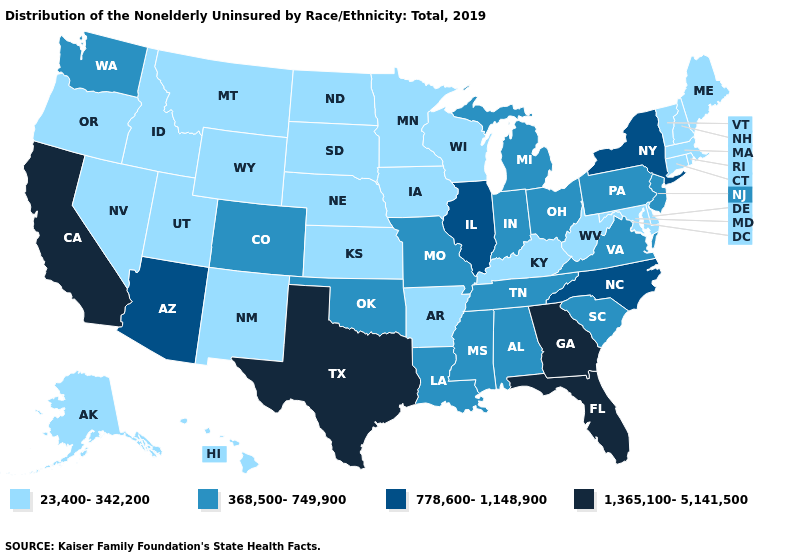Name the states that have a value in the range 23,400-342,200?
Write a very short answer. Alaska, Arkansas, Connecticut, Delaware, Hawaii, Idaho, Iowa, Kansas, Kentucky, Maine, Maryland, Massachusetts, Minnesota, Montana, Nebraska, Nevada, New Hampshire, New Mexico, North Dakota, Oregon, Rhode Island, South Dakota, Utah, Vermont, West Virginia, Wisconsin, Wyoming. Name the states that have a value in the range 778,600-1,148,900?
Write a very short answer. Arizona, Illinois, New York, North Carolina. Does West Virginia have the lowest value in the South?
Write a very short answer. Yes. What is the highest value in the USA?
Concise answer only. 1,365,100-5,141,500. Does the map have missing data?
Keep it brief. No. Name the states that have a value in the range 368,500-749,900?
Write a very short answer. Alabama, Colorado, Indiana, Louisiana, Michigan, Mississippi, Missouri, New Jersey, Ohio, Oklahoma, Pennsylvania, South Carolina, Tennessee, Virginia, Washington. Among the states that border Illinois , which have the highest value?
Write a very short answer. Indiana, Missouri. Name the states that have a value in the range 23,400-342,200?
Short answer required. Alaska, Arkansas, Connecticut, Delaware, Hawaii, Idaho, Iowa, Kansas, Kentucky, Maine, Maryland, Massachusetts, Minnesota, Montana, Nebraska, Nevada, New Hampshire, New Mexico, North Dakota, Oregon, Rhode Island, South Dakota, Utah, Vermont, West Virginia, Wisconsin, Wyoming. Does Washington have a higher value than Georgia?
Answer briefly. No. Which states have the lowest value in the USA?
Answer briefly. Alaska, Arkansas, Connecticut, Delaware, Hawaii, Idaho, Iowa, Kansas, Kentucky, Maine, Maryland, Massachusetts, Minnesota, Montana, Nebraska, Nevada, New Hampshire, New Mexico, North Dakota, Oregon, Rhode Island, South Dakota, Utah, Vermont, West Virginia, Wisconsin, Wyoming. Does New York have the highest value in the Northeast?
Short answer required. Yes. What is the value of Maine?
Write a very short answer. 23,400-342,200. How many symbols are there in the legend?
Be succinct. 4. Among the states that border New Jersey , does Delaware have the lowest value?
Short answer required. Yes. What is the value of Texas?
Short answer required. 1,365,100-5,141,500. 